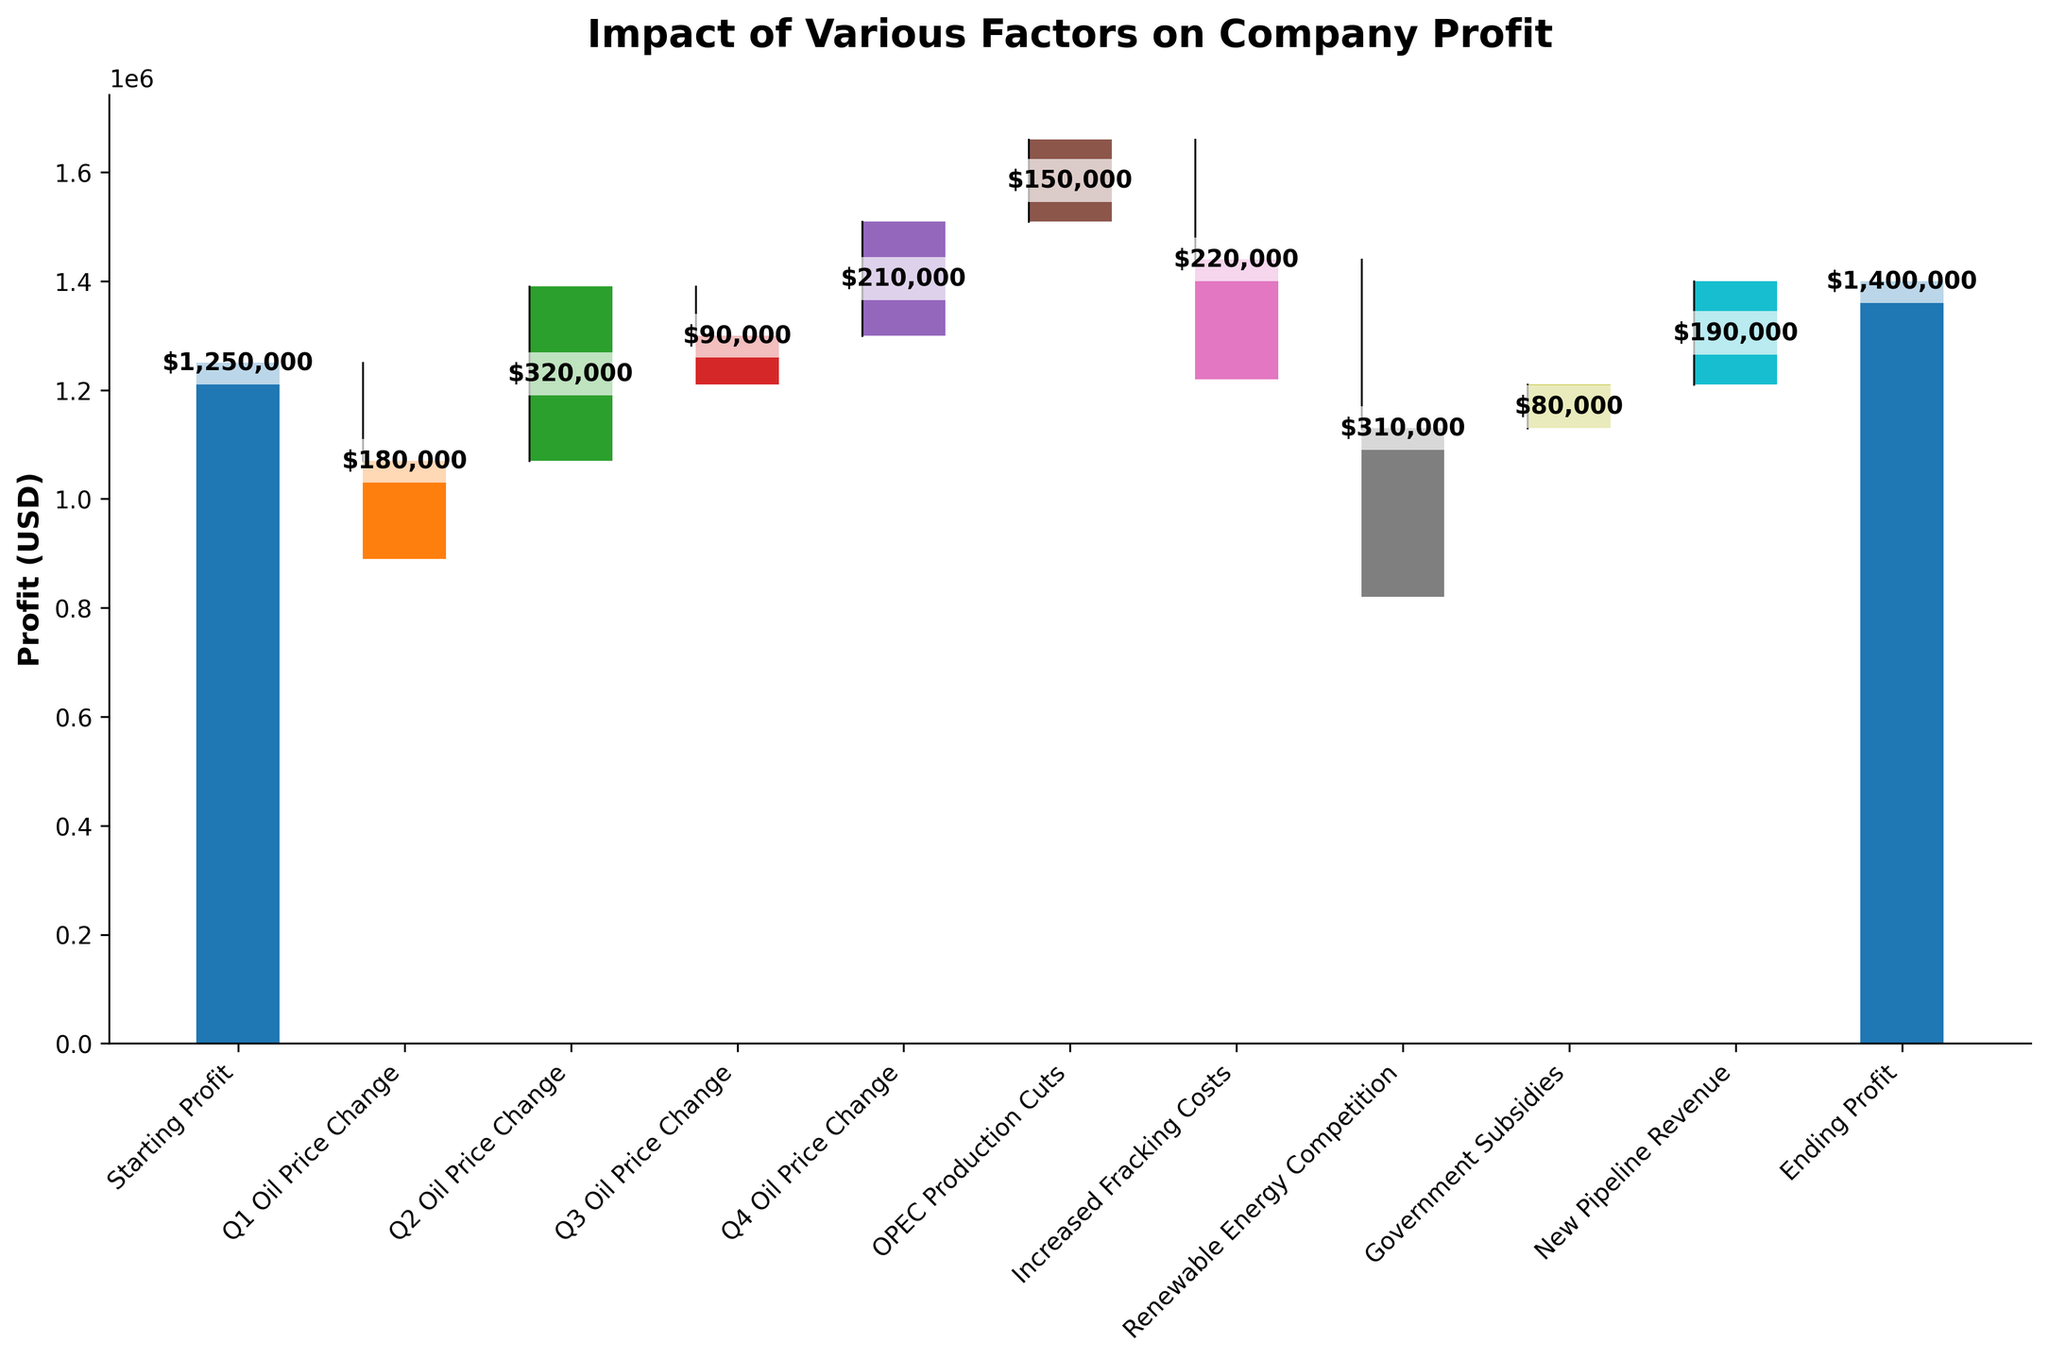What is the title of the chart? The title of the chart is located at the top of the figure and provides an overview of what the chart represents.
Answer: Impact of Various Factors on Company Profit How many categories are there in the chart? The categories can be counted as they are listed along the x-axis of the waterfall chart.
Answer: 11 What is the starting profit value? The starting profit value is represented by the first bar in the chart and also labeled.
Answer: $1,250,000 Which factor had the most negative impact on the profit? By comparing the length of all the downward (negative) bars, the factor with the longest downward bar represents the largest negative impact.
Answer: Renewable Energy Competition What is the ending profit value? The ending profit value is represented by the last bar in the chart and is also labeled.
Answer: $1,400,000 How much did 'Government Subsidies' add to the profit? 'Government Subsidies' bar can be found in the categories along the x-axis, and the value of this bar can be checked.
Answer: $80,000 What is the overall net change in profit from 'Starting Profit' to 'Ending Profit'? The net change is calculated by subtracting 'Starting Profit' from 'Ending Profit': $1,400,000 - $1,250,000
Answer: $150,000 How does 'Increased Fracking Costs' compare to 'New Pipeline Revenue'? Compare the bar lengths and values of 'Increased Fracking Costs' and 'New Pipeline Revenue'.
Answer: Increased Fracking Costs are greater in negative value How did Q2 Oil Price Change affect the profit? The value of the Q2 Oil Price Change would be visually found in the corresponding bar.
Answer: Increased by $320,000 What is the cumulative effect of all quarterly oil price changes on the profit? Sum all quarterly oil price changes (Q1 Oil Price Change, Q2 Oil Price Change, Q3 Oil Price Change, Q4 Oil Price Change): -$180,000 + $320,000 - $90,000 + $210,000
Answer: $260,000 